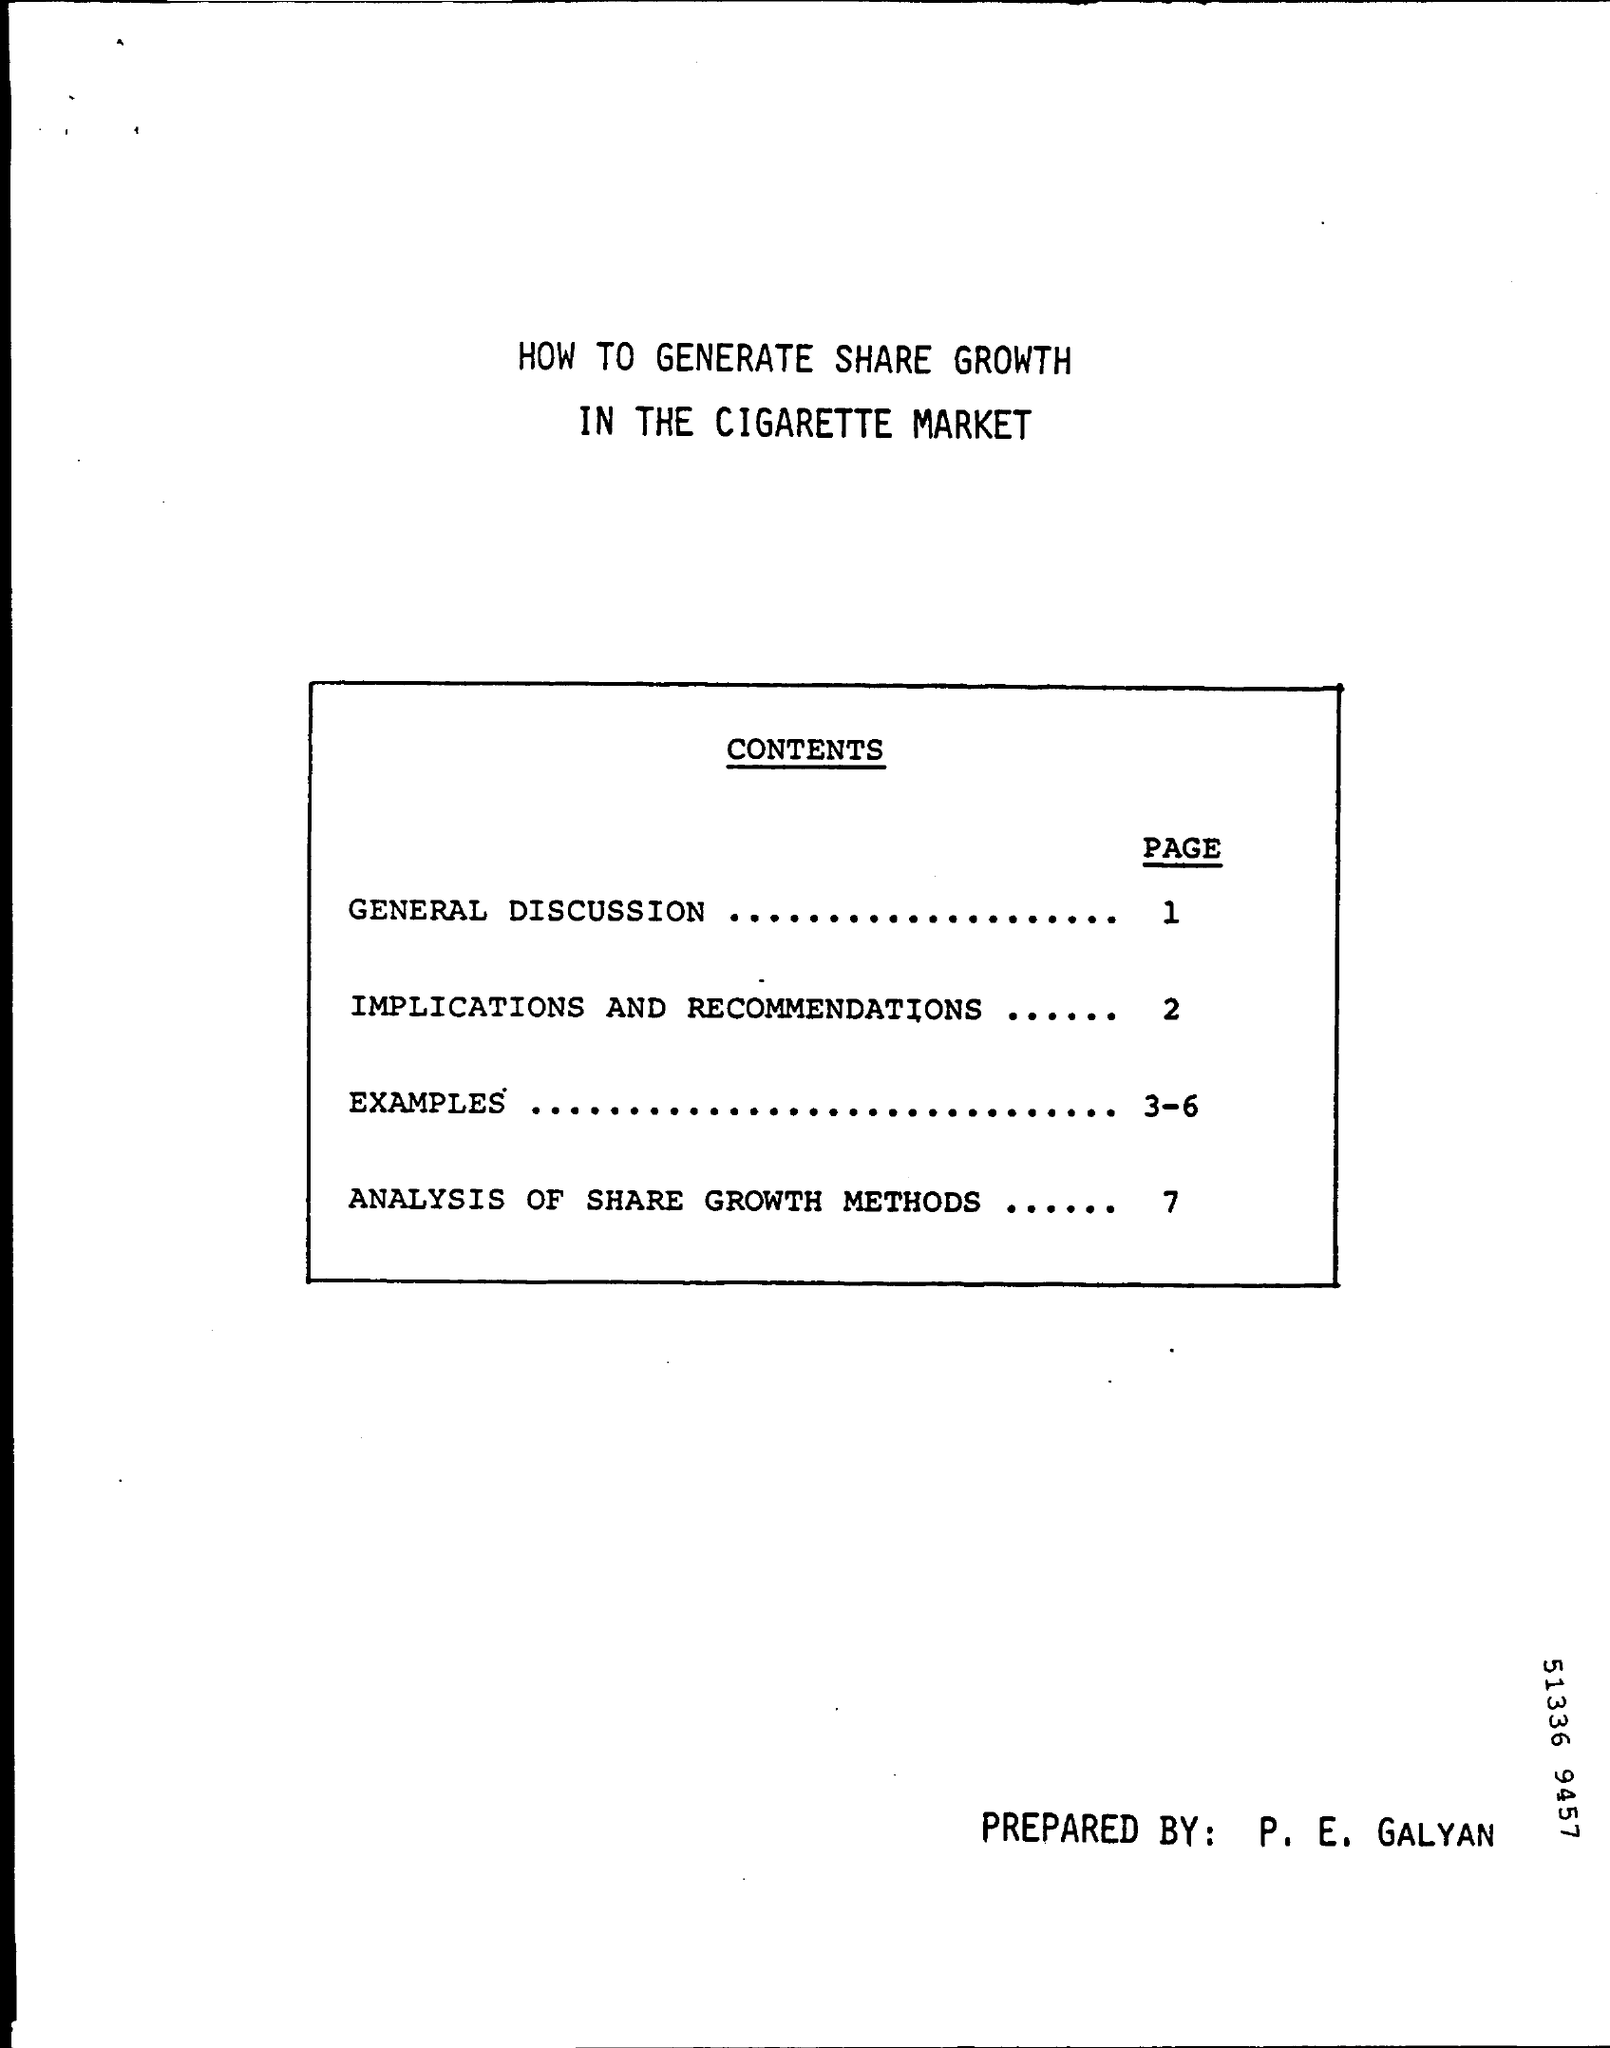Indicate a few pertinent items in this graphic. The preparation of this document was performed by P. E. GALYAN. Examples can be found on pages 3-6. The text displays the page number "1" for the General Discussion. 